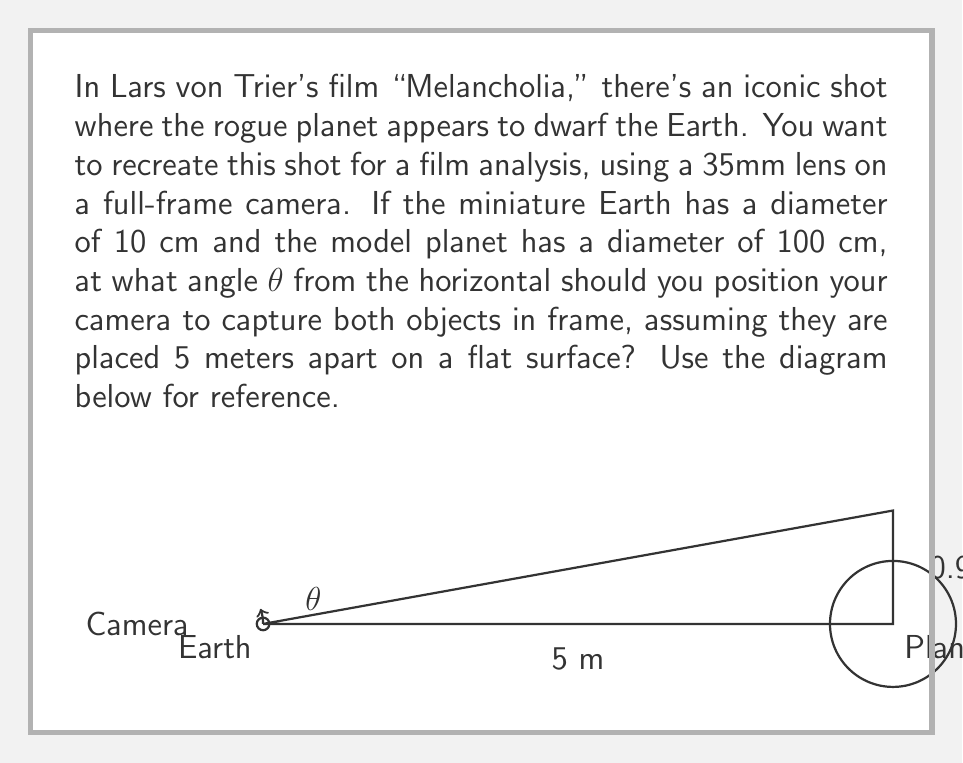Show me your answer to this math problem. To solve this problem, we need to use trigonometry. Let's approach this step-by-step:

1) First, we need to find the height difference between the centers of the two objects. 
   The Earth's radius is 5 cm, and the planet's radius is 50 cm.
   Height difference = 50 cm - 5 cm = 45 cm = 0.45 m

2) Now we have a right triangle with:
   - Base = 5 m (distance between objects)
   - Height = 0.45 m (difference in center heights)
   - Angle θ (what we're solving for)

3) We can use the tangent function to find θ:

   $$\tan(\theta) = \frac{\text{opposite}}{\text{adjacent}} = \frac{0.45}{5}$$

4) To solve for θ, we use the inverse tangent (arctangent) function:

   $$\theta = \arctan(\frac{0.45}{5})$$

5) Using a calculator or computer:

   $$\theta \approx 0.0897 \text{ radians}$$

6) Convert to degrees:

   $$\theta \approx 0.0897 \times \frac{180}{\pi} \approx 5.14°$$

Therefore, the camera should be positioned at an angle of approximately 5.14° from the horizontal.
Answer: $\theta \approx 5.14°$ 